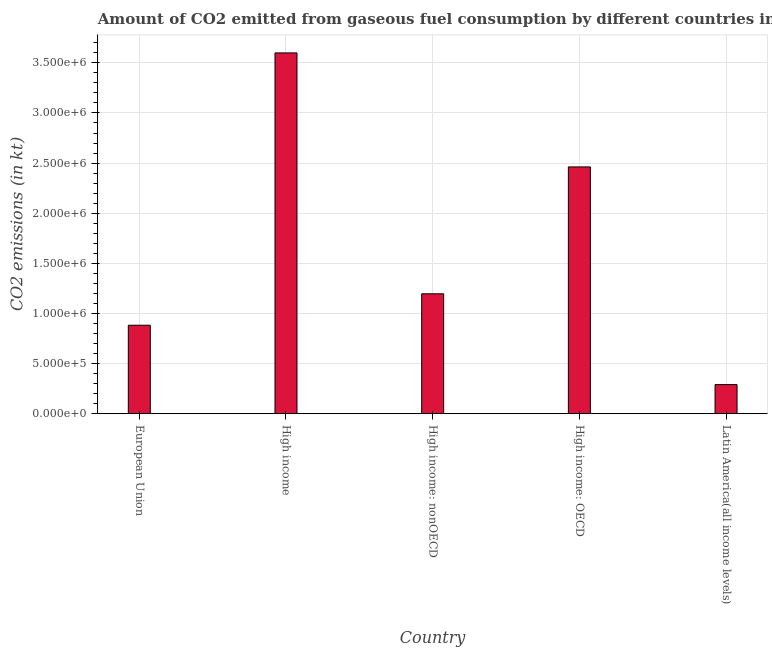Does the graph contain any zero values?
Your answer should be very brief. No. What is the title of the graph?
Provide a succinct answer. Amount of CO2 emitted from gaseous fuel consumption by different countries in 1999. What is the label or title of the X-axis?
Keep it short and to the point. Country. What is the label or title of the Y-axis?
Your answer should be compact. CO2 emissions (in kt). What is the co2 emissions from gaseous fuel consumption in European Union?
Offer a very short reply. 8.83e+05. Across all countries, what is the maximum co2 emissions from gaseous fuel consumption?
Your answer should be compact. 3.60e+06. Across all countries, what is the minimum co2 emissions from gaseous fuel consumption?
Make the answer very short. 2.90e+05. In which country was the co2 emissions from gaseous fuel consumption maximum?
Provide a short and direct response. High income. In which country was the co2 emissions from gaseous fuel consumption minimum?
Your answer should be very brief. Latin America(all income levels). What is the sum of the co2 emissions from gaseous fuel consumption?
Your response must be concise. 8.43e+06. What is the difference between the co2 emissions from gaseous fuel consumption in High income: OECD and Latin America(all income levels)?
Your response must be concise. 2.17e+06. What is the average co2 emissions from gaseous fuel consumption per country?
Keep it short and to the point. 1.69e+06. What is the median co2 emissions from gaseous fuel consumption?
Your answer should be compact. 1.20e+06. In how many countries, is the co2 emissions from gaseous fuel consumption greater than 1700000 kt?
Make the answer very short. 2. What is the ratio of the co2 emissions from gaseous fuel consumption in High income: OECD to that in High income: nonOECD?
Provide a short and direct response. 2.06. Is the co2 emissions from gaseous fuel consumption in High income less than that in Latin America(all income levels)?
Offer a terse response. No. What is the difference between the highest and the second highest co2 emissions from gaseous fuel consumption?
Offer a terse response. 1.14e+06. Is the sum of the co2 emissions from gaseous fuel consumption in European Union and High income greater than the maximum co2 emissions from gaseous fuel consumption across all countries?
Offer a very short reply. Yes. What is the difference between the highest and the lowest co2 emissions from gaseous fuel consumption?
Give a very brief answer. 3.31e+06. How many bars are there?
Provide a short and direct response. 5. Are all the bars in the graph horizontal?
Provide a succinct answer. No. Are the values on the major ticks of Y-axis written in scientific E-notation?
Keep it short and to the point. Yes. What is the CO2 emissions (in kt) of European Union?
Ensure brevity in your answer.  8.83e+05. What is the CO2 emissions (in kt) of High income?
Your answer should be very brief. 3.60e+06. What is the CO2 emissions (in kt) in High income: nonOECD?
Your response must be concise. 1.20e+06. What is the CO2 emissions (in kt) of High income: OECD?
Your answer should be very brief. 2.46e+06. What is the CO2 emissions (in kt) in Latin America(all income levels)?
Offer a terse response. 2.90e+05. What is the difference between the CO2 emissions (in kt) in European Union and High income?
Keep it short and to the point. -2.72e+06. What is the difference between the CO2 emissions (in kt) in European Union and High income: nonOECD?
Provide a short and direct response. -3.14e+05. What is the difference between the CO2 emissions (in kt) in European Union and High income: OECD?
Provide a succinct answer. -1.58e+06. What is the difference between the CO2 emissions (in kt) in European Union and Latin America(all income levels)?
Keep it short and to the point. 5.92e+05. What is the difference between the CO2 emissions (in kt) in High income and High income: nonOECD?
Keep it short and to the point. 2.40e+06. What is the difference between the CO2 emissions (in kt) in High income and High income: OECD?
Ensure brevity in your answer.  1.14e+06. What is the difference between the CO2 emissions (in kt) in High income and Latin America(all income levels)?
Provide a short and direct response. 3.31e+06. What is the difference between the CO2 emissions (in kt) in High income: nonOECD and High income: OECD?
Your answer should be compact. -1.27e+06. What is the difference between the CO2 emissions (in kt) in High income: nonOECD and Latin America(all income levels)?
Give a very brief answer. 9.06e+05. What is the difference between the CO2 emissions (in kt) in High income: OECD and Latin America(all income levels)?
Your answer should be very brief. 2.17e+06. What is the ratio of the CO2 emissions (in kt) in European Union to that in High income?
Provide a succinct answer. 0.24. What is the ratio of the CO2 emissions (in kt) in European Union to that in High income: nonOECD?
Make the answer very short. 0.74. What is the ratio of the CO2 emissions (in kt) in European Union to that in High income: OECD?
Offer a very short reply. 0.36. What is the ratio of the CO2 emissions (in kt) in European Union to that in Latin America(all income levels)?
Ensure brevity in your answer.  3.04. What is the ratio of the CO2 emissions (in kt) in High income to that in High income: nonOECD?
Your response must be concise. 3.01. What is the ratio of the CO2 emissions (in kt) in High income to that in High income: OECD?
Provide a succinct answer. 1.46. What is the ratio of the CO2 emissions (in kt) in High income to that in Latin America(all income levels)?
Make the answer very short. 12.39. What is the ratio of the CO2 emissions (in kt) in High income: nonOECD to that in High income: OECD?
Your answer should be compact. 0.49. What is the ratio of the CO2 emissions (in kt) in High income: nonOECD to that in Latin America(all income levels)?
Your answer should be very brief. 4.12. What is the ratio of the CO2 emissions (in kt) in High income: OECD to that in Latin America(all income levels)?
Give a very brief answer. 8.47. 